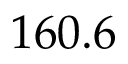Convert formula to latex. <formula><loc_0><loc_0><loc_500><loc_500>1 6 0 . 6</formula> 